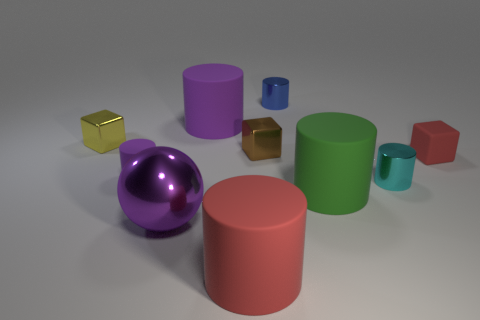There is a thing that is both in front of the brown shiny object and on the left side of the big purple metal object; how big is it?
Your response must be concise. Small. There is a green object; are there any large matte things in front of it?
Your response must be concise. Yes. What number of objects are tiny matte things that are to the left of the big purple cylinder or cyan cylinders?
Make the answer very short. 2. What number of blue objects are in front of the metallic cylinder that is left of the large green rubber cylinder?
Offer a very short reply. 0. Is the number of big green rubber things behind the brown metallic block less than the number of red matte things that are behind the big red matte cylinder?
Make the answer very short. Yes. There is a large purple object in front of the block that is on the right side of the cyan metallic thing; what shape is it?
Make the answer very short. Sphere. What number of other objects are there of the same material as the brown thing?
Ensure brevity in your answer.  4. Is the number of tiny matte cylinders greater than the number of small rubber objects?
Ensure brevity in your answer.  No. There is a metal cylinder behind the block that is on the left side of the purple cylinder that is in front of the brown shiny object; what is its size?
Provide a short and direct response. Small. Is the size of the red matte cylinder the same as the purple cylinder that is behind the rubber block?
Your answer should be very brief. Yes. 